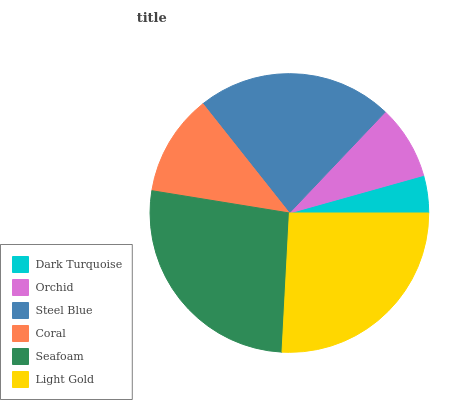Is Dark Turquoise the minimum?
Answer yes or no. Yes. Is Seafoam the maximum?
Answer yes or no. Yes. Is Orchid the minimum?
Answer yes or no. No. Is Orchid the maximum?
Answer yes or no. No. Is Orchid greater than Dark Turquoise?
Answer yes or no. Yes. Is Dark Turquoise less than Orchid?
Answer yes or no. Yes. Is Dark Turquoise greater than Orchid?
Answer yes or no. No. Is Orchid less than Dark Turquoise?
Answer yes or no. No. Is Steel Blue the high median?
Answer yes or no. Yes. Is Coral the low median?
Answer yes or no. Yes. Is Seafoam the high median?
Answer yes or no. No. Is Dark Turquoise the low median?
Answer yes or no. No. 